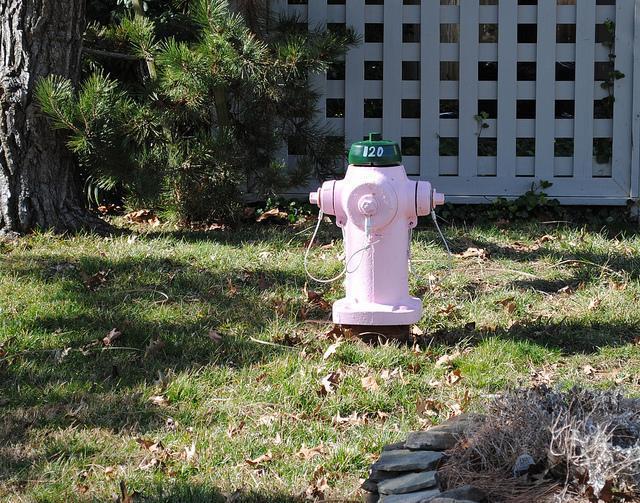How many stories of the building can be seen?
Give a very brief answer. 0. How many green buses are on the road?
Give a very brief answer. 0. 